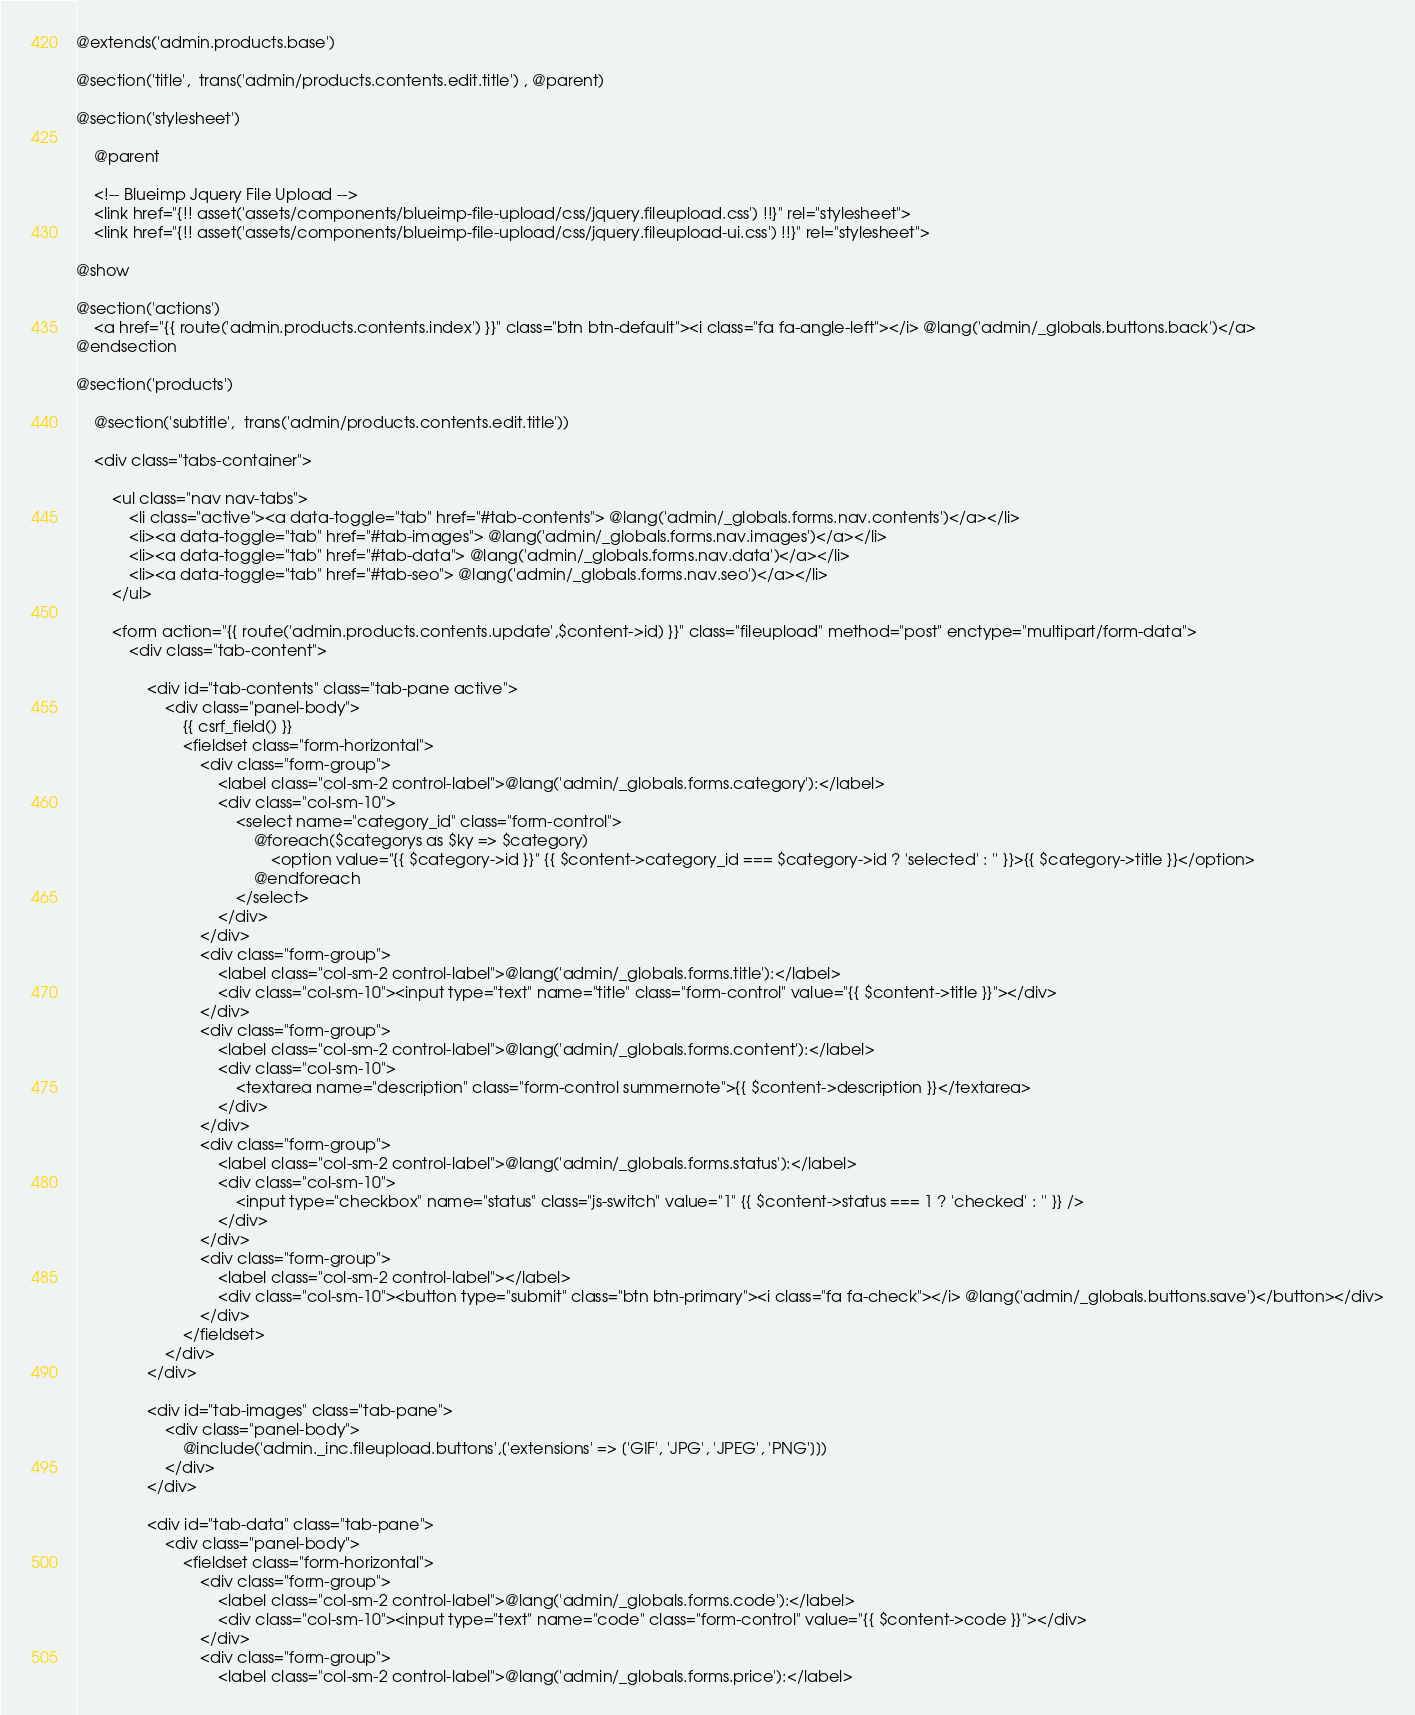Convert code to text. <code><loc_0><loc_0><loc_500><loc_500><_PHP_>@extends('admin.products.base')

@section('title',  trans('admin/products.contents.edit.title') , @parent)

@section('stylesheet')

    @parent
    
    <!-- Blueimp Jquery File Upload -->
    <link href="{!! asset('assets/components/blueimp-file-upload/css/jquery.fileupload.css') !!}" rel="stylesheet">
    <link href="{!! asset('assets/components/blueimp-file-upload/css/jquery.fileupload-ui.css') !!}" rel="stylesheet">

@show

@section('actions')
    <a href="{{ route('admin.products.contents.index') }}" class="btn btn-default"><i class="fa fa-angle-left"></i> @lang('admin/_globals.buttons.back')</a>
@endsection

@section('products')
	
	@section('subtitle',  trans('admin/products.contents.edit.title'))

	<div class="tabs-container">

        <ul class="nav nav-tabs">
            <li class="active"><a data-toggle="tab" href="#tab-contents"> @lang('admin/_globals.forms.nav.contents')</a></li>
            <li><a data-toggle="tab" href="#tab-images"> @lang('admin/_globals.forms.nav.images')</a></li>
            <li><a data-toggle="tab" href="#tab-data"> @lang('admin/_globals.forms.nav.data')</a></li>
            <li><a data-toggle="tab" href="#tab-seo"> @lang('admin/_globals.forms.nav.seo')</a></li>
        </ul>

		<form action="{{ route('admin.products.contents.update',$content->id) }}" class="fileupload" method="post" enctype="multipart/form-data">
            <div class="tab-content">

                <div id="tab-contents" class="tab-pane active">
                    <div class="panel-body">
                        {{ csrf_field() }}
                        <fieldset class="form-horizontal">
                            <div class="form-group">
                                <label class="col-sm-2 control-label">@lang('admin/_globals.forms.category'):</label>
                                <div class="col-sm-10">
                                    <select name="category_id" class="form-control">
                                        @foreach($categorys as $ky => $category)
                                            <option value="{{ $category->id }}" {{ $content->category_id === $category->id ? 'selected' : '' }}>{{ $category->title }}</option>
                                        @endforeach
                                    </select>
                                </div>
                            </div>
                            <div class="form-group">
                                <label class="col-sm-2 control-label">@lang('admin/_globals.forms.title'):</label>
                                <div class="col-sm-10"><input type="text" name="title" class="form-control" value="{{ $content->title }}"></div>
                            </div>
                            <div class="form-group">
                                <label class="col-sm-2 control-label">@lang('admin/_globals.forms.content'):</label>
                                <div class="col-sm-10">
                                    <textarea name="description" class="form-control summernote">{{ $content->description }}</textarea>
                                </div>
                            </div>
                            <div class="form-group">
                                <label class="col-sm-2 control-label">@lang('admin/_globals.forms.status'):</label>
                                <div class="col-sm-10">
                                    <input type="checkbox" name="status" class="js-switch" value="1" {{ $content->status === 1 ? 'checked' : '' }} />
                                </div>
                            </div>
                            <div class="form-group">
                                <label class="col-sm-2 control-label"></label>
                                <div class="col-sm-10"><button type="submit" class="btn btn-primary"><i class="fa fa-check"></i> @lang('admin/_globals.buttons.save')</button></div>
                            </div>
                        </fieldset>
                    </div>
                </div>

                <div id="tab-images" class="tab-pane">
                    <div class="panel-body">
                        @include('admin._inc.fileupload.buttons',['extensions' => ['GIF', 'JPG', 'JPEG', 'PNG']])
                    </div>
                </div>

                <div id="tab-data" class="tab-pane">
                    <div class="panel-body">
                        <fieldset class="form-horizontal">
                            <div class="form-group">
                                <label class="col-sm-2 control-label">@lang('admin/_globals.forms.code'):</label>
                                <div class="col-sm-10"><input type="text" name="code" class="form-control" value="{{ $content->code }}"></div>
                            </div>
                            <div class="form-group">
                                <label class="col-sm-2 control-label">@lang('admin/_globals.forms.price'):</label></code> 